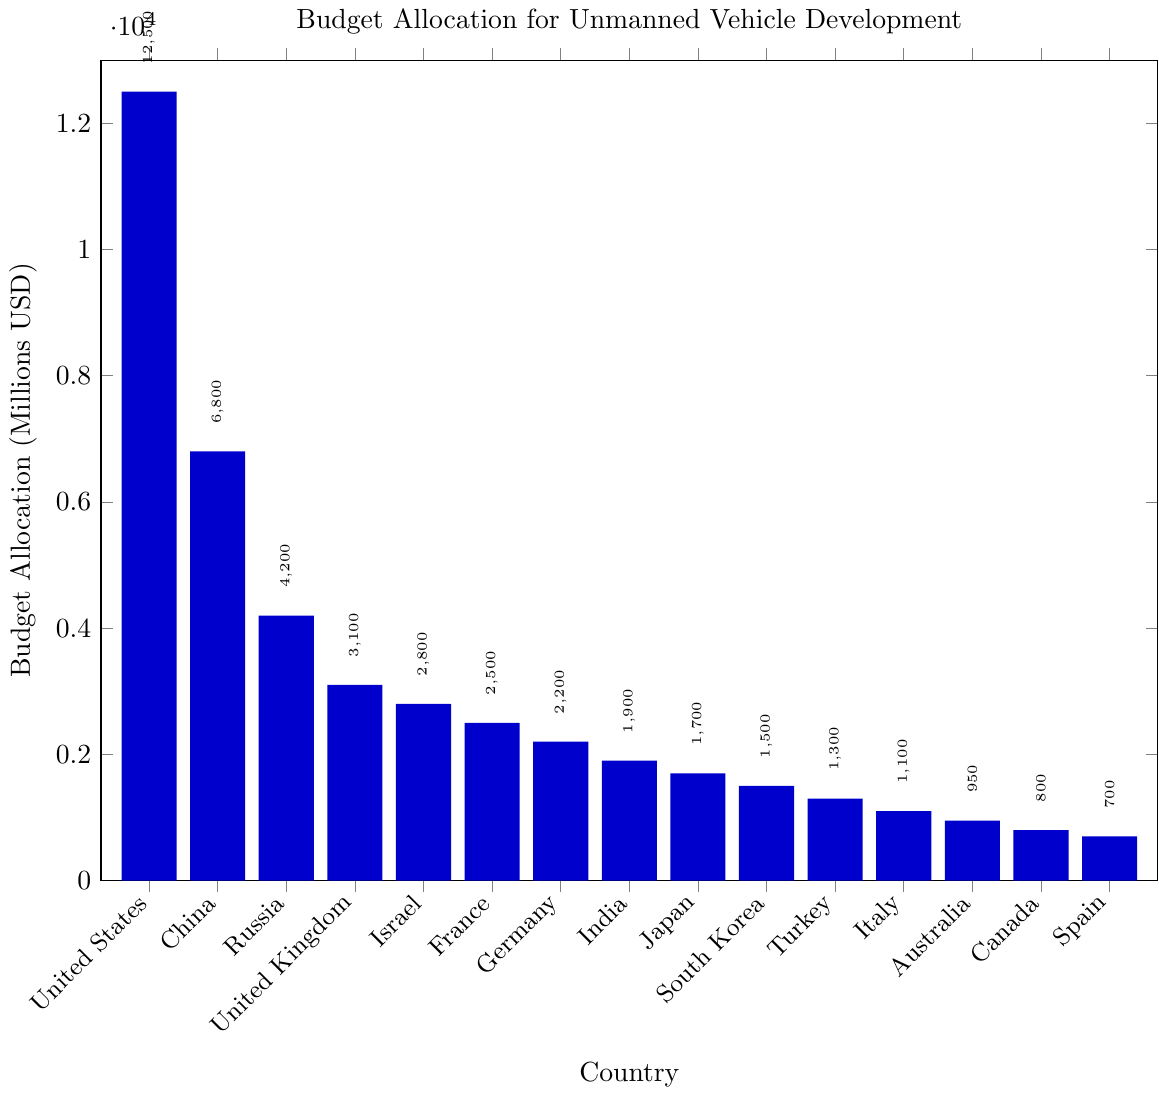What's the total budget allocation for the top three countries combined? Add the budget allocations of the United States, China, and Russia: 12500 + 6800 + 4200 = 23500
Answer: 23500 Which country has the lowest budget allocation for unmanned vehicle development? The figure shows that Spain has the lowest budget allocation of 700 million USD.
Answer: Spain Which three countries have a budget allocation greater than 4000 million USD? The figure displays three countries: United States (12500), China (6800), and Russia (4200), all with budgets greater than 4000 million USD.
Answer: United States, China, Russia By how much does the budget allocation of the United States exceed the combined budget allocations of Germany and France? Subtract the combined allocations of Germany (2200) and France (2500) from the United States' allocation (12500): 12500 - (2200 + 2500) = 12500 - 4700 = 7800
Answer: 7800 Rank the countries in descending order of their budget allocation. The order from highest to lowest budget allocation is: United States, China, Russia, United Kingdom, Israel, France, Germany, India, Japan, South Korea, Turkey, Italy, Australia, Canada, Spain.
Answer: United States, China, Russia, United Kingdom, Israel, France, Germany, India, Japan, South Korea, Turkey, Italy, Australia, Canada, Spain What is the difference in budget allocation between Japan and South Korea? Subtract South Korea's budget (1500) from Japan's budget (1700): 1700 - 1500 = 200
Answer: 200 Which country beside the United States has the highest budget allocation, and how much is it? According to the bar chart, China has the second highest budget allocation after the United States, totaling 6800 million USD.
Answer: China, 6800 How much more is the budget allocation of Israel compared to that of Turkey? Subtract Turkey's budget (1300) from Israel's budget (2800): 2800 - 1300 = 1500
Answer: 1500 Find the median budget allocation of the given countries. Arrange the 15 budgets in ascending order: 700, 800, 950, 1100, 1300, 1500, 1700, 1900, 2200, 2500, 2800, 3100, 4200, 6800, 12500. The median is the 8th value, which is 1900.
Answer: 1900 